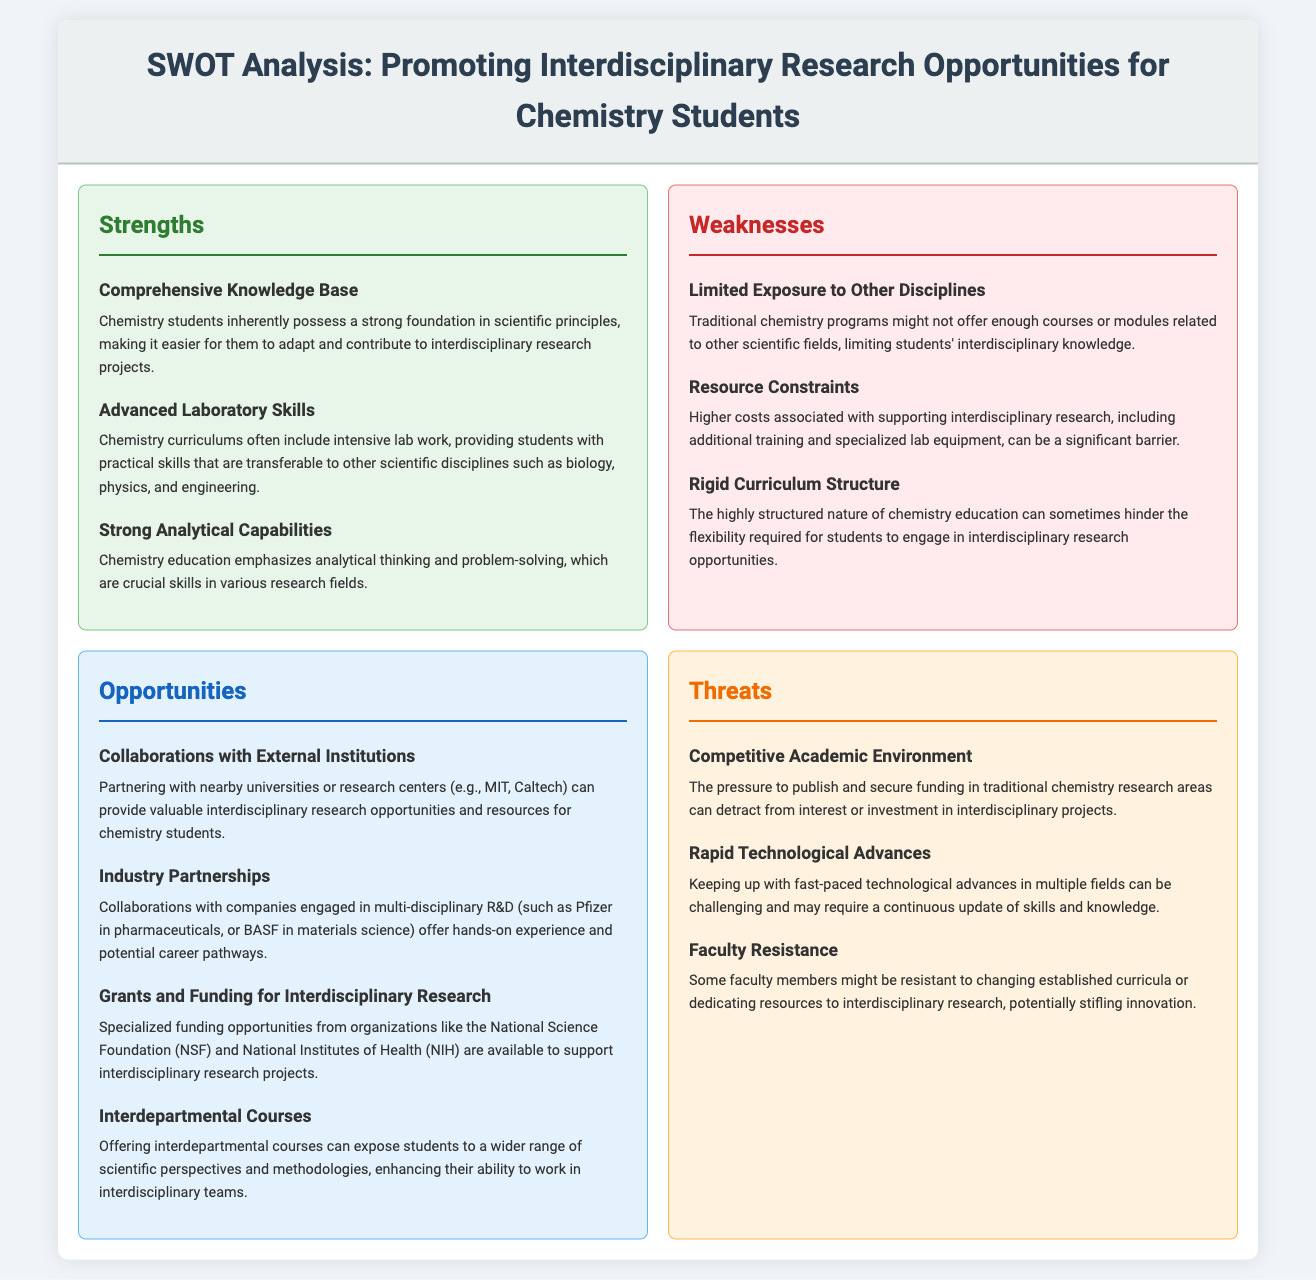What are the primary strengths identified in the SWOT analysis? The strengths are listed under the "Strengths" section, including comprehensive knowledge base, advanced laboratory skills, and strong analytical capabilities.
Answer: Comprehensive knowledge base, advanced laboratory skills, strong analytical capabilities Which organization is mentioned in relation to grants for interdisciplinary research? The document mentions the National Science Foundation (NSF) and National Institutes of Health (NIH) in the "Opportunities" section.
Answer: National Science Foundation, National Institutes of Health What is one of the weaknesses regarding chemistry students' exposure? This weakness is found in the "Weaknesses" section of the document, specifically stating limited exposure to other disciplines.
Answer: Limited exposure to other disciplines Which industry partnership is highlighted as an opportunity for hands-on experience? The document states that partnering with companies like Pfizer can provide such experience under the "Opportunities" section.
Answer: Pfizer What is a potential threat related to faculty behavior? The "Threats" section indicates that faculty resistance to change could stifle innovation as a threat to interdisciplinary research.
Answer: Faculty resistance How many areas are listed under the 'Strengths' section? The document outlines three areas listed under the "Strengths" section related to interdisciplinary research opportunities.
Answer: Three What is emphasized as a significant barrier in the 'Weaknesses' section? The 'Weaknesses' section emphasizes resource constraints associated with supporting interdisciplinary research as a barrier.
Answer: Resource constraints Which type of collaborations are suggested to provide valuable research opportunities? The collaboration with nearby universities or research centers is suggested in the "Opportunities" section.
Answer: Collaborations with nearby universities or research centers What is highlighted as a challenge in keeping pace with technological advancements? The document states that rapid technological advances can be challenging to keep up with under the "Threats" section.
Answer: Rapid technological advances 